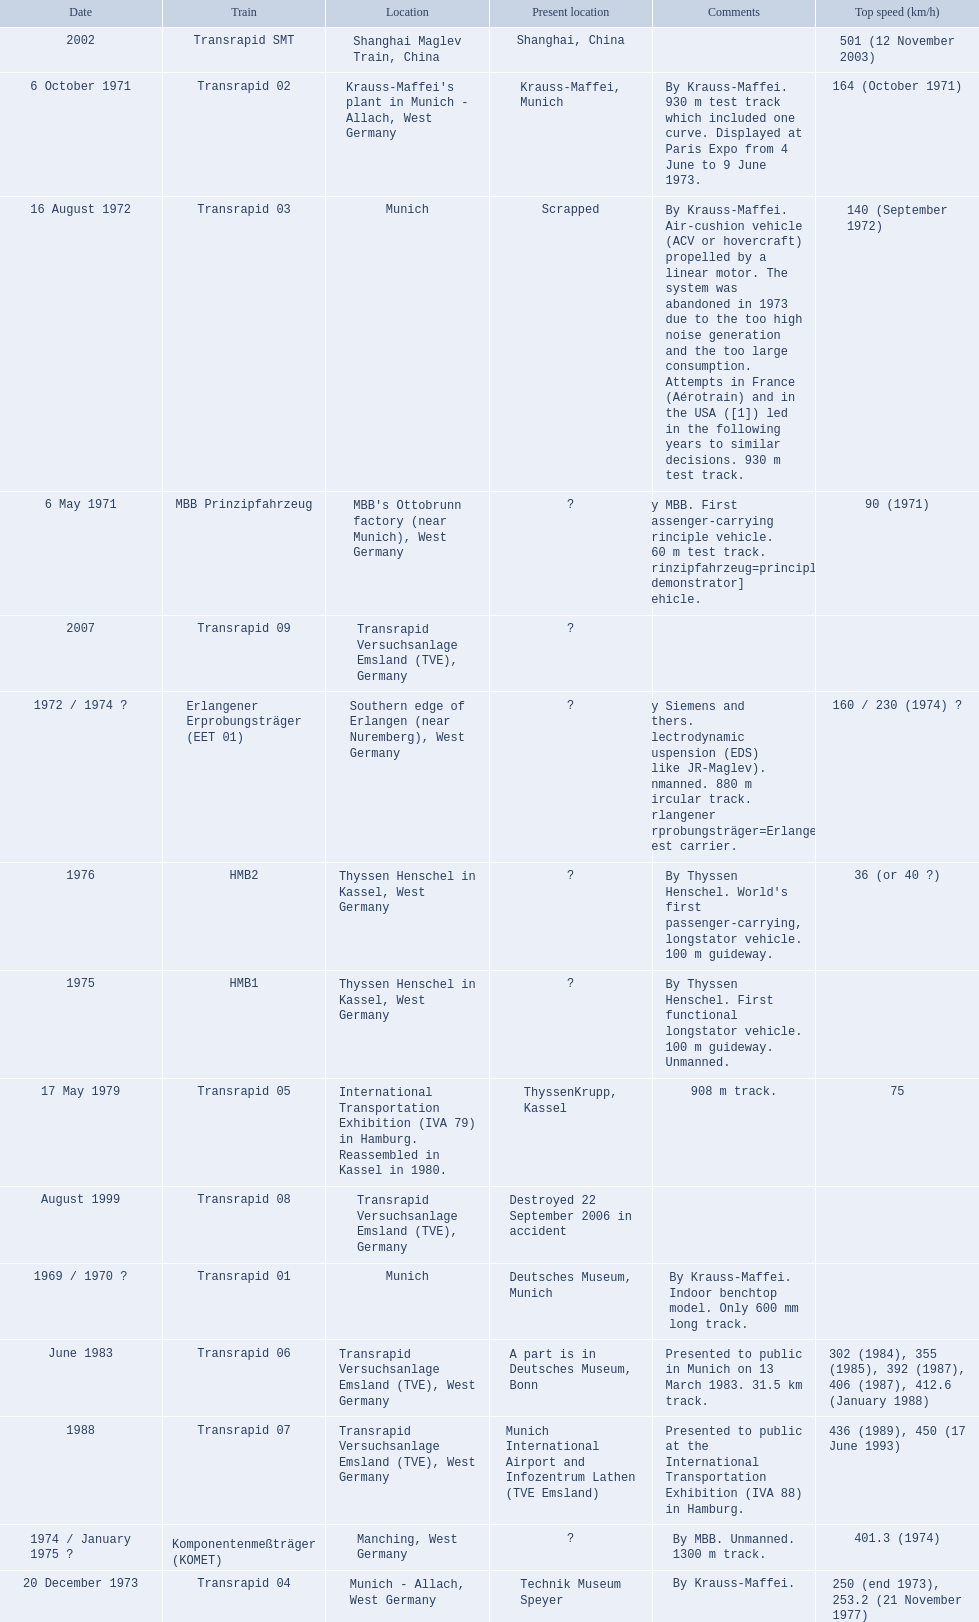Which trains had a top speed listed? MBB Prinzipfahrzeug, Transrapid 02, Transrapid 03, Erlangener Erprobungsträger (EET 01), Transrapid 04, Komponentenmeßträger (KOMET), HMB2, Transrapid 05, Transrapid 06, Transrapid 07, Transrapid SMT. Which ones list munich as a location? MBB Prinzipfahrzeug, Transrapid 02, Transrapid 03. Of these which ones present location is known? Transrapid 02, Transrapid 03. Parse the full table in json format. {'header': ['Date', 'Train', 'Location', 'Present location', 'Comments', 'Top speed (km/h)'], 'rows': [['2002', 'Transrapid SMT', 'Shanghai Maglev Train, China', 'Shanghai, China', '', '501 (12 November 2003)'], ['6 October 1971', 'Transrapid 02', "Krauss-Maffei's plant in Munich - Allach, West Germany", 'Krauss-Maffei, Munich', 'By Krauss-Maffei. 930 m test track which included one curve. Displayed at Paris Expo from 4 June to 9 June 1973.', '164 (October 1971)'], ['16 August 1972', 'Transrapid 03', 'Munich', 'Scrapped', 'By Krauss-Maffei. Air-cushion vehicle (ACV or hovercraft) propelled by a linear motor. The system was abandoned in 1973 due to the too high noise generation and the too large consumption. Attempts in France (Aérotrain) and in the USA ([1]) led in the following years to similar decisions. 930 m test track.', '140 (September 1972)'], ['6 May 1971', 'MBB Prinzipfahrzeug', "MBB's Ottobrunn factory (near Munich), West Germany", '?', 'By MBB. First passenger-carrying principle vehicle. 660 m test track. Prinzipfahrzeug=principle [demonstrator] vehicle.', '90 (1971)'], ['2007', 'Transrapid 09', 'Transrapid Versuchsanlage Emsland (TVE), Germany', '?', '', ''], ['1972 / 1974\xa0?', 'Erlangener Erprobungsträger (EET 01)', 'Southern edge of Erlangen (near Nuremberg), West Germany', '?', 'By Siemens and others. Electrodynamic suspension (EDS) (like JR-Maglev). Unmanned. 880 m circular track. Erlangener Erprobungsträger=Erlangen test carrier.', '160 / 230 (1974)\xa0?'], ['1976', 'HMB2', 'Thyssen Henschel in Kassel, West Germany', '?', "By Thyssen Henschel. World's first passenger-carrying, longstator vehicle. 100 m guideway.", '36 (or 40\xa0?)'], ['1975', 'HMB1', 'Thyssen Henschel in Kassel, West Germany', '?', 'By Thyssen Henschel. First functional longstator vehicle. 100 m guideway. Unmanned.', ''], ['17 May 1979', 'Transrapid 05', 'International Transportation Exhibition (IVA 79) in Hamburg. Reassembled in Kassel in 1980.', 'ThyssenKrupp, Kassel', '908 m track.', '75'], ['August 1999', 'Transrapid 08', 'Transrapid Versuchsanlage Emsland (TVE), Germany', 'Destroyed 22 September 2006 in accident', '', ''], ['1969 / 1970\xa0?', 'Transrapid 01', 'Munich', 'Deutsches Museum, Munich', 'By Krauss-Maffei. Indoor benchtop model. Only 600\xa0mm long track.', ''], ['June 1983', 'Transrapid 06', 'Transrapid Versuchsanlage Emsland (TVE), West Germany', 'A part is in Deutsches Museum, Bonn', 'Presented to public in Munich on 13 March 1983. 31.5\xa0km track.', '302 (1984), 355 (1985), 392 (1987), 406 (1987), 412.6 (January 1988)'], ['1988', 'Transrapid 07', 'Transrapid Versuchsanlage Emsland (TVE), West Germany', 'Munich International Airport and Infozentrum Lathen (TVE Emsland)', 'Presented to public at the International Transportation Exhibition (IVA 88) in Hamburg.', '436 (1989), 450 (17 June 1993)'], ['1974 / January 1975\xa0?', 'Komponentenmeßträger (KOMET)', 'Manching, West Germany', '?', 'By MBB. Unmanned. 1300 m track.', '401.3 (1974)'], ['20 December 1973', 'Transrapid 04', 'Munich - Allach, West Germany', 'Technik Museum Speyer', 'By Krauss-Maffei.', '250 (end 1973), 253.2 (21 November 1977)']]} Which of those is no longer in operation? Transrapid 03. 